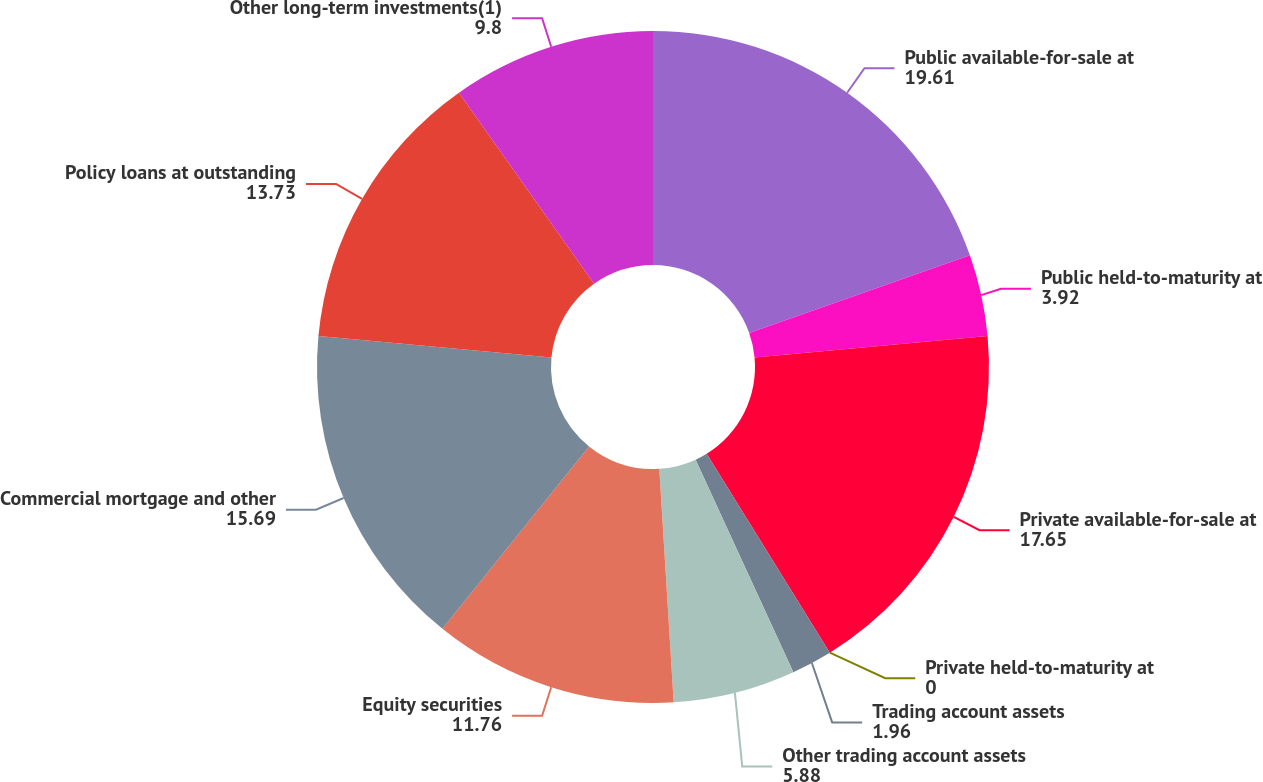<chart> <loc_0><loc_0><loc_500><loc_500><pie_chart><fcel>Public available-for-sale at<fcel>Public held-to-maturity at<fcel>Private available-for-sale at<fcel>Private held-to-maturity at<fcel>Trading account assets<fcel>Other trading account assets<fcel>Equity securities<fcel>Commercial mortgage and other<fcel>Policy loans at outstanding<fcel>Other long-term investments(1)<nl><fcel>19.61%<fcel>3.92%<fcel>17.65%<fcel>0.0%<fcel>1.96%<fcel>5.88%<fcel>11.76%<fcel>15.69%<fcel>13.73%<fcel>9.8%<nl></chart> 